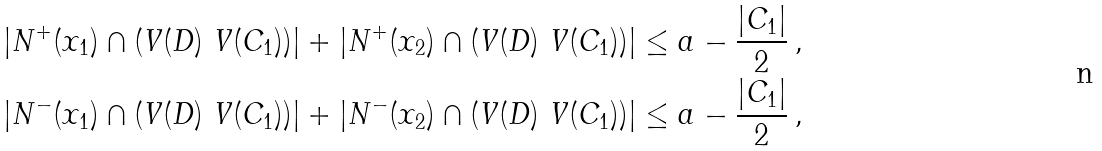Convert formula to latex. <formula><loc_0><loc_0><loc_500><loc_500>| N ^ { + } ( x _ { 1 } ) \cap ( V ( D ) \ V ( C _ { 1 } ) ) | + | N ^ { + } ( x _ { 2 } ) \cap ( V ( D ) \ V ( C _ { 1 } ) ) | & \leq a - \frac { | C _ { 1 } | } { 2 } \, , \\ | N ^ { - } ( x _ { 1 } ) \cap ( V ( D ) \ V ( C _ { 1 } ) ) | + | N ^ { - } ( x _ { 2 } ) \cap ( V ( D ) \ V ( C _ { 1 } ) ) | & \leq a - \frac { | C _ { 1 } | } { 2 } \, ,</formula> 